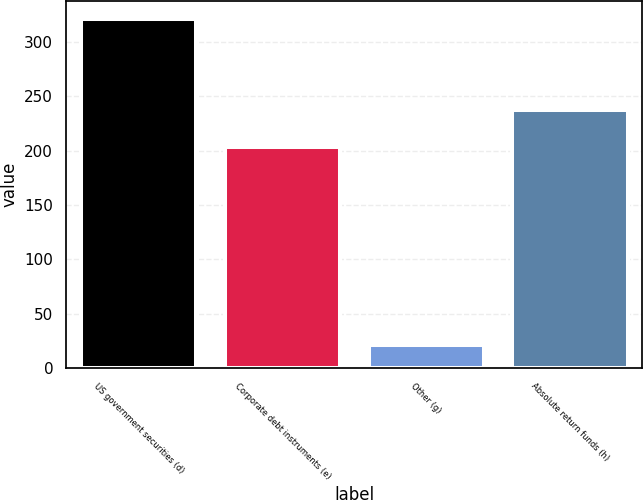Convert chart. <chart><loc_0><loc_0><loc_500><loc_500><bar_chart><fcel>US government securities (d)<fcel>Corporate debt instruments (e)<fcel>Other (g)<fcel>Absolute return funds (h)<nl><fcel>321<fcel>203<fcel>21<fcel>237<nl></chart> 